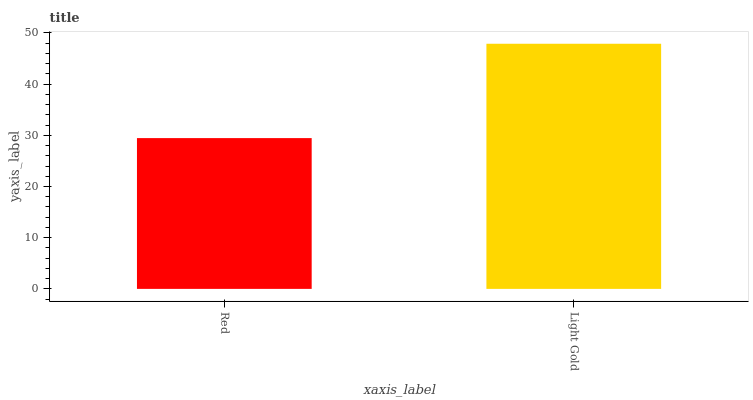Is Red the minimum?
Answer yes or no. Yes. Is Light Gold the maximum?
Answer yes or no. Yes. Is Light Gold the minimum?
Answer yes or no. No. Is Light Gold greater than Red?
Answer yes or no. Yes. Is Red less than Light Gold?
Answer yes or no. Yes. Is Red greater than Light Gold?
Answer yes or no. No. Is Light Gold less than Red?
Answer yes or no. No. Is Light Gold the high median?
Answer yes or no. Yes. Is Red the low median?
Answer yes or no. Yes. Is Red the high median?
Answer yes or no. No. Is Light Gold the low median?
Answer yes or no. No. 